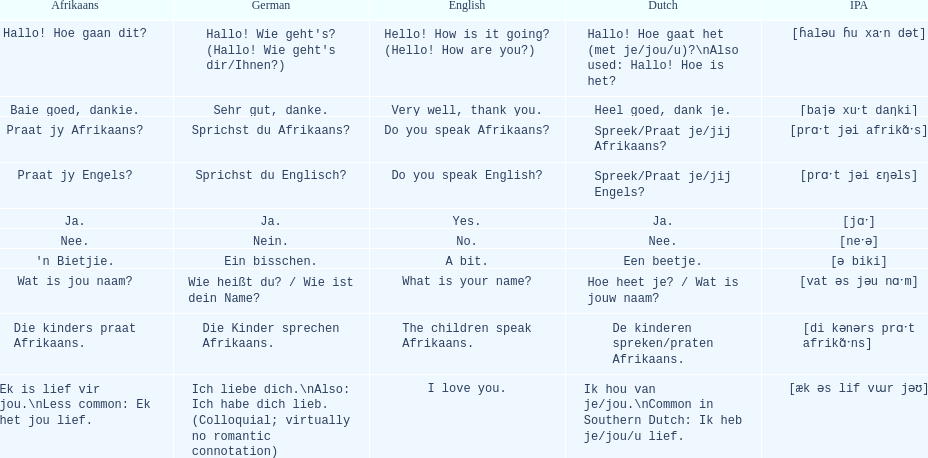How do you say 'i love you' in afrikaans? Ek is lief vir jou. 